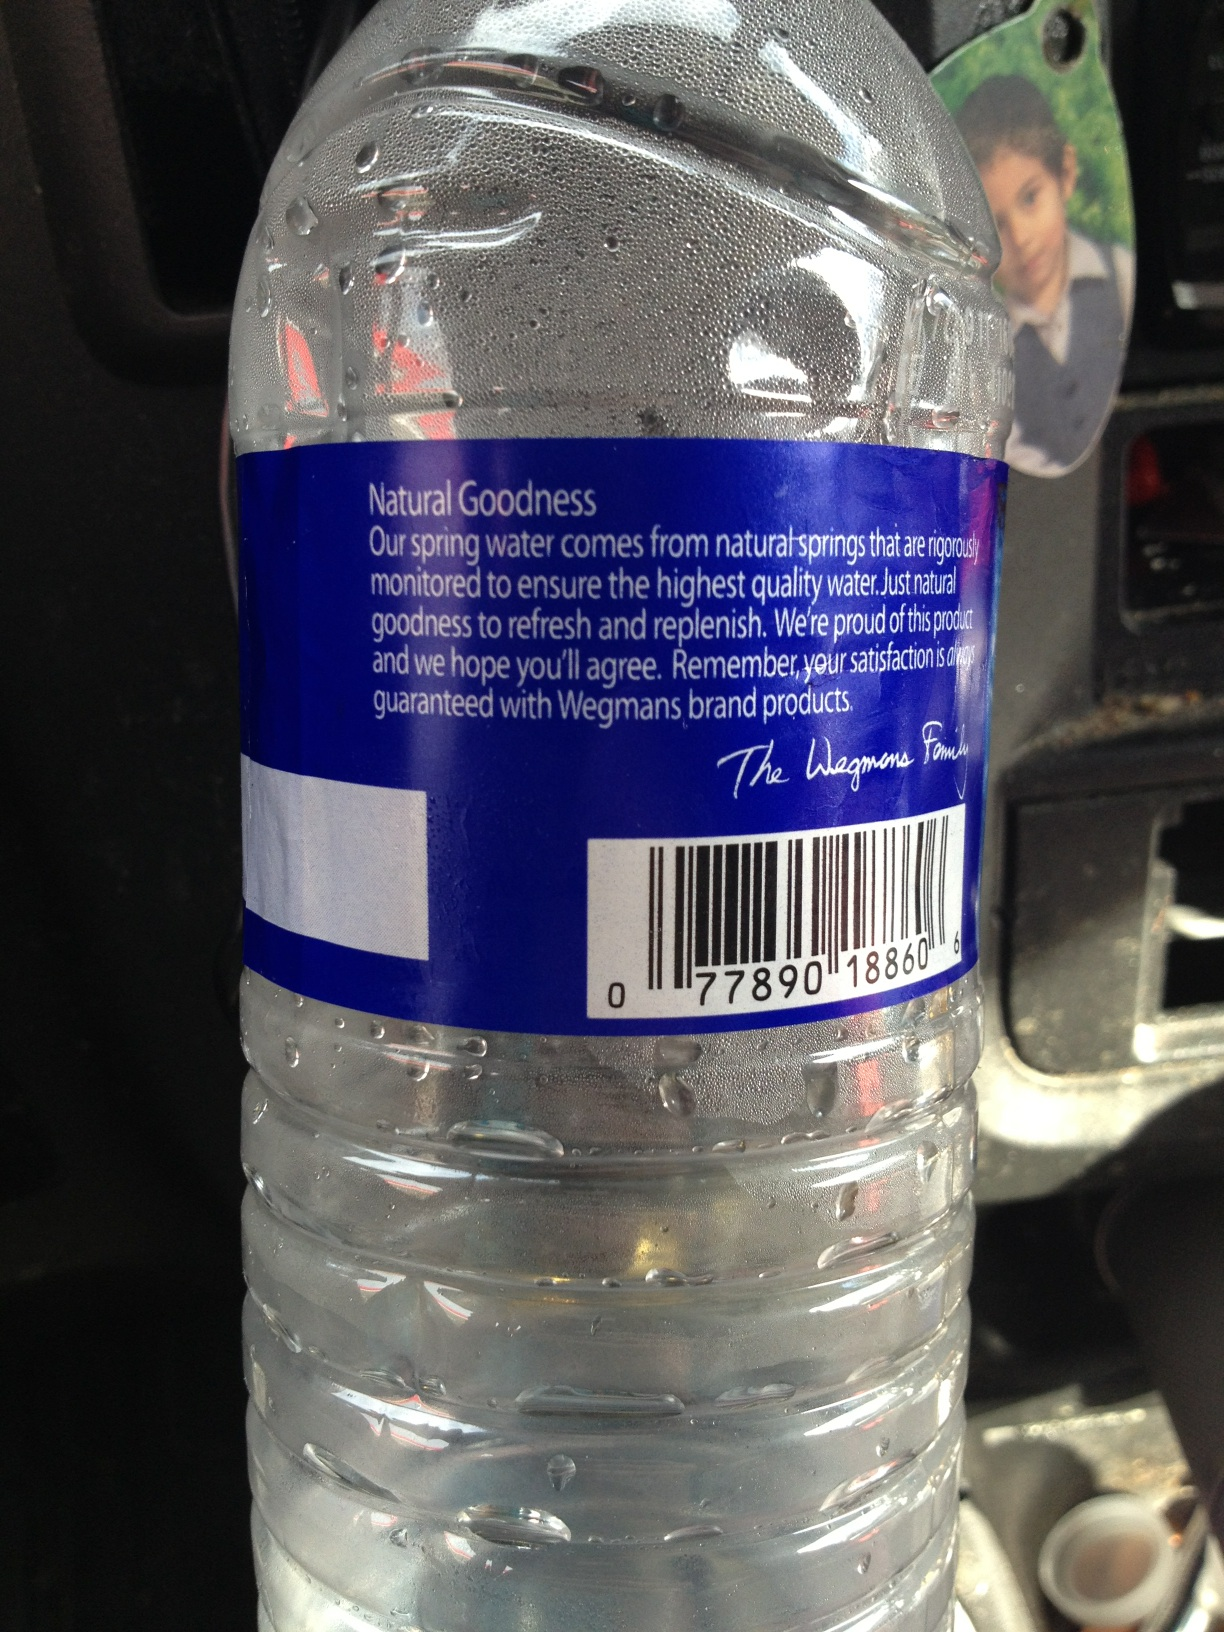Describe an extremely detailed and creative scenario involving this water bottle. Picture this: a group of explorers are trekking through an uncharted rainforest. Among their essential gear, each carries a Wegmans Natural Spring Water bottle. These bottles aren’t just for hydration – their clear, ripple-designed surfaces are fitted with technology that reads air quality, providing real-time updates on the environment. In the middle of their journey, they set up camp near a hidden waterfall. As twilight descends, they discover their water bottles have bioluminescent properties, glowing gently and lighting up their surroundings. Each sip replenishes their energy, thanks to the electrolytes naturally present from the spring’s minerals. This bottle keeps them hydrated, informed about their environment, and lights up their nights as they explore the mysteries of the uncharted world. 